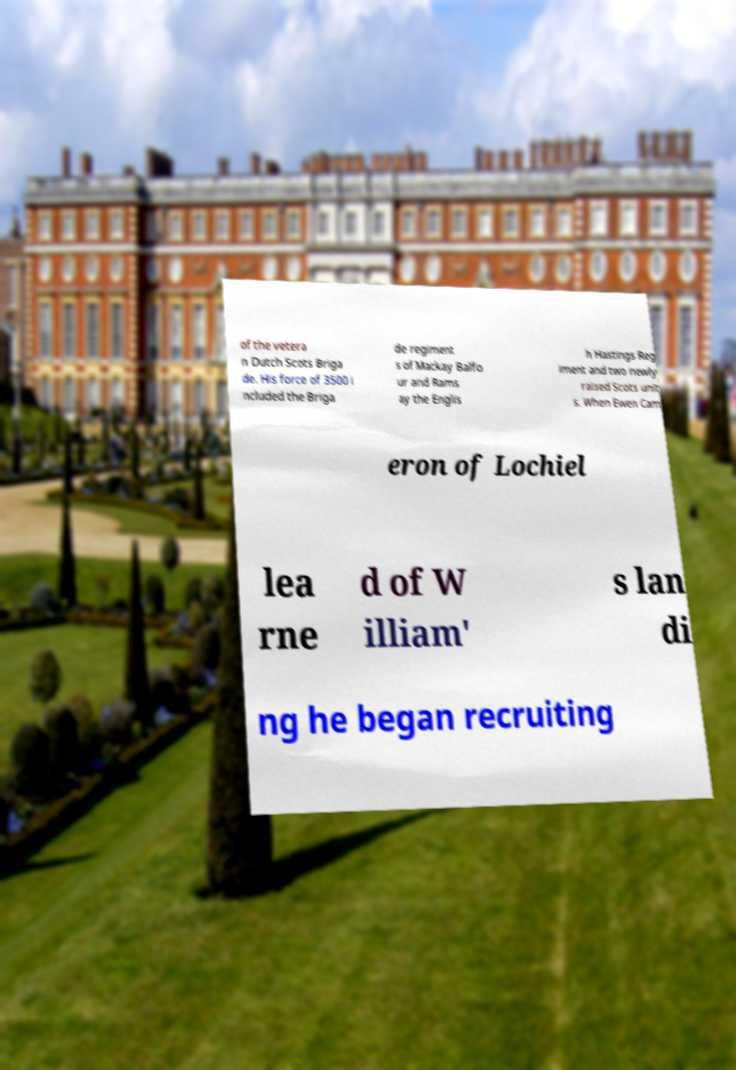Please identify and transcribe the text found in this image. of the vetera n Dutch Scots Briga de. His force of 3500 i ncluded the Briga de regiment s of Mackay Balfo ur and Rams ay the Englis h Hastings Reg iment and two newly raised Scots unit s. When Ewen Cam eron of Lochiel lea rne d of W illiam' s lan di ng he began recruiting 